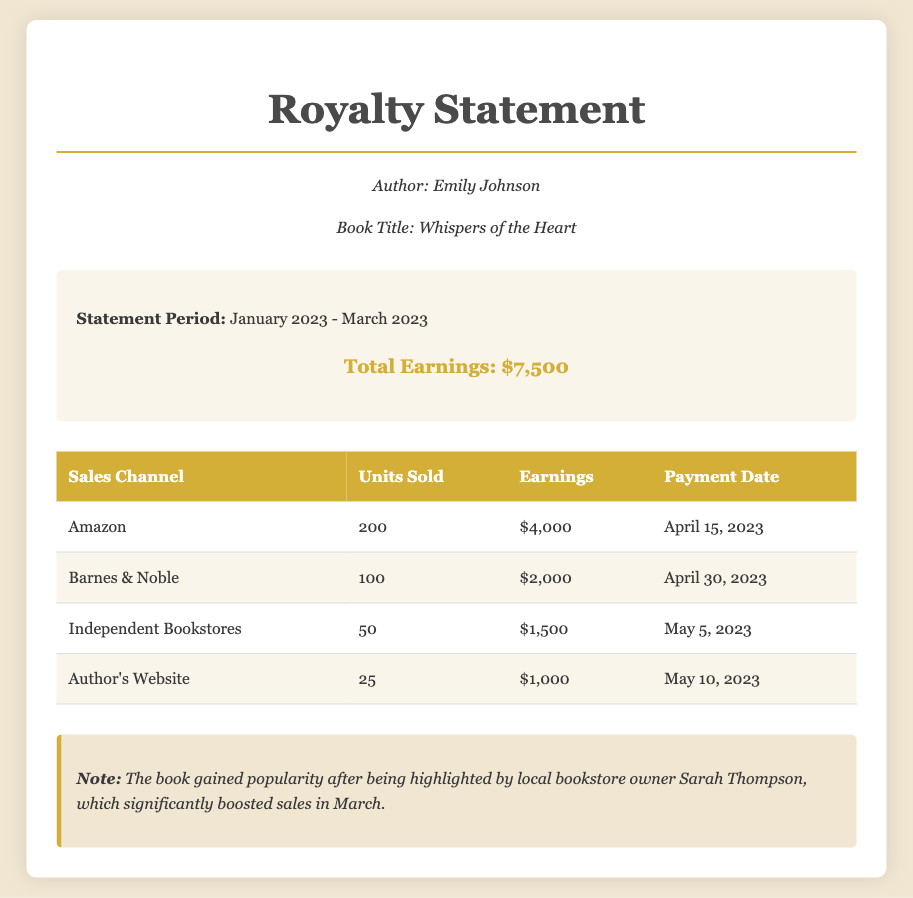What is the author's name? The author's name is mentioned in the document as Emily Johnson.
Answer: Emily Johnson What is the book title? The document states the title of the book is Whispers of the Heart.
Answer: Whispers of the Heart What is the total earnings for the statement period? The total earnings are summarized in the document as $7,500.
Answer: $7,500 How many units were sold through Amazon? The document specifies that 200 units were sold through Amazon.
Answer: 200 What is the payment date for Barnes & Noble sales? The payment date for Barnes & Noble sales is listed as April 30, 2023.
Answer: April 30, 2023 Which sales channel generated the highest earnings? The highest earnings are generated through Amazon, which made $4,000.
Answer: Amazon What was the statement period for this royalty statement? The statement period is clearly stated in the document as January 2023 - March 2023.
Answer: January 2023 - March 2023 How many units were sold through the author's website? The document indicates that 25 units were sold through the author's website.
Answer: 25 What note is provided regarding the book's popularity? The note discusses how local bookstore owner Sarah Thompson highlighted the book, boosting sales in March.
Answer: Sarah Thompson highlighted the book, boosting sales 